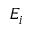Convert formula to latex. <formula><loc_0><loc_0><loc_500><loc_500>E _ { i }</formula> 